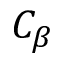Convert formula to latex. <formula><loc_0><loc_0><loc_500><loc_500>C _ { \beta }</formula> 